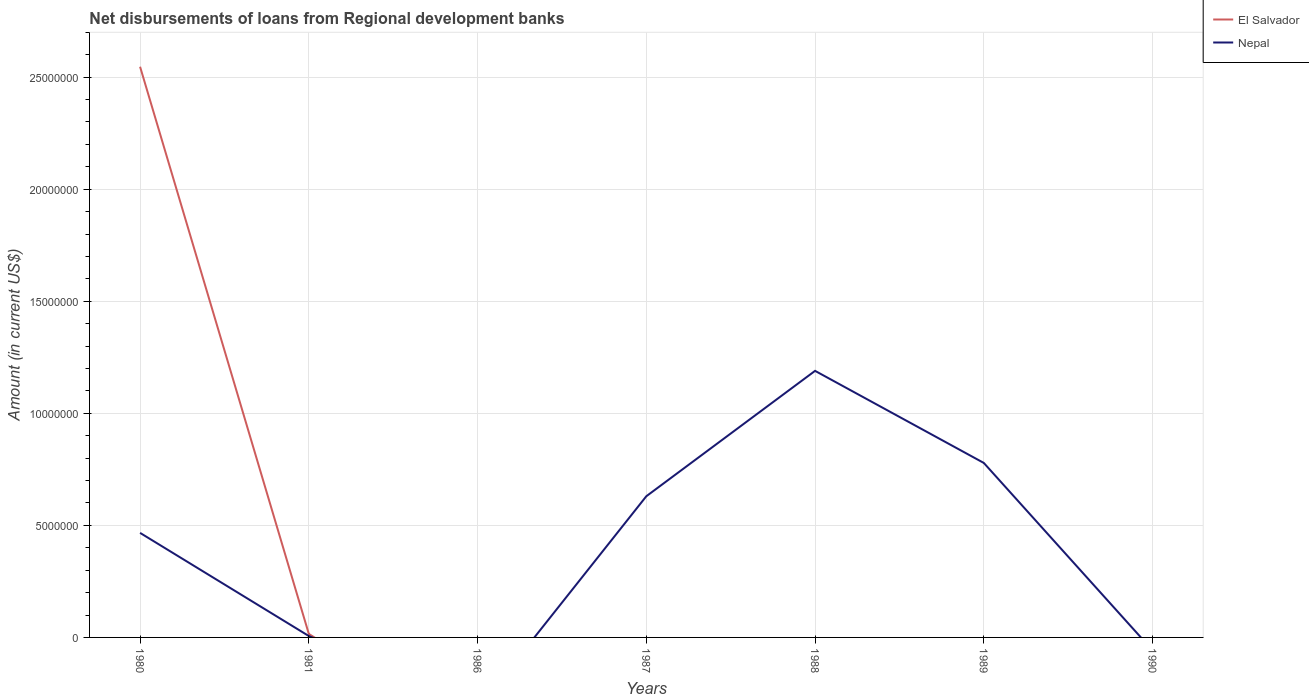How many different coloured lines are there?
Keep it short and to the point. 2. Does the line corresponding to Nepal intersect with the line corresponding to El Salvador?
Provide a succinct answer. Yes. Is the number of lines equal to the number of legend labels?
Make the answer very short. No. Across all years, what is the maximum amount of disbursements of loans from regional development banks in El Salvador?
Make the answer very short. 0. What is the total amount of disbursements of loans from regional development banks in Nepal in the graph?
Make the answer very short. -5.60e+06. What is the difference between the highest and the second highest amount of disbursements of loans from regional development banks in El Salvador?
Keep it short and to the point. 2.55e+07. Is the amount of disbursements of loans from regional development banks in Nepal strictly greater than the amount of disbursements of loans from regional development banks in El Salvador over the years?
Make the answer very short. No. How many years are there in the graph?
Offer a terse response. 7. Are the values on the major ticks of Y-axis written in scientific E-notation?
Provide a succinct answer. No. Does the graph contain any zero values?
Your answer should be very brief. Yes. How are the legend labels stacked?
Make the answer very short. Vertical. What is the title of the graph?
Offer a very short reply. Net disbursements of loans from Regional development banks. What is the label or title of the X-axis?
Your response must be concise. Years. What is the label or title of the Y-axis?
Provide a short and direct response. Amount (in current US$). What is the Amount (in current US$) in El Salvador in 1980?
Offer a very short reply. 2.55e+07. What is the Amount (in current US$) of Nepal in 1980?
Offer a terse response. 4.66e+06. What is the Amount (in current US$) of El Salvador in 1981?
Keep it short and to the point. 1.56e+05. What is the Amount (in current US$) in Nepal in 1981?
Offer a very short reply. 6.30e+04. What is the Amount (in current US$) in El Salvador in 1986?
Offer a very short reply. 0. What is the Amount (in current US$) in Nepal in 1986?
Offer a terse response. 0. What is the Amount (in current US$) in Nepal in 1987?
Offer a terse response. 6.30e+06. What is the Amount (in current US$) of El Salvador in 1988?
Make the answer very short. 0. What is the Amount (in current US$) in Nepal in 1988?
Your answer should be compact. 1.19e+07. What is the Amount (in current US$) in El Salvador in 1989?
Provide a succinct answer. 0. What is the Amount (in current US$) in Nepal in 1989?
Give a very brief answer. 7.79e+06. Across all years, what is the maximum Amount (in current US$) in El Salvador?
Make the answer very short. 2.55e+07. Across all years, what is the maximum Amount (in current US$) of Nepal?
Make the answer very short. 1.19e+07. Across all years, what is the minimum Amount (in current US$) in El Salvador?
Give a very brief answer. 0. Across all years, what is the minimum Amount (in current US$) in Nepal?
Provide a short and direct response. 0. What is the total Amount (in current US$) of El Salvador in the graph?
Provide a succinct answer. 2.56e+07. What is the total Amount (in current US$) of Nepal in the graph?
Your response must be concise. 3.07e+07. What is the difference between the Amount (in current US$) of El Salvador in 1980 and that in 1981?
Your answer should be compact. 2.53e+07. What is the difference between the Amount (in current US$) of Nepal in 1980 and that in 1981?
Your answer should be very brief. 4.60e+06. What is the difference between the Amount (in current US$) of Nepal in 1980 and that in 1987?
Your response must be concise. -1.64e+06. What is the difference between the Amount (in current US$) of Nepal in 1980 and that in 1988?
Make the answer very short. -7.23e+06. What is the difference between the Amount (in current US$) in Nepal in 1980 and that in 1989?
Your answer should be compact. -3.12e+06. What is the difference between the Amount (in current US$) in Nepal in 1981 and that in 1987?
Provide a succinct answer. -6.24e+06. What is the difference between the Amount (in current US$) in Nepal in 1981 and that in 1988?
Give a very brief answer. -1.18e+07. What is the difference between the Amount (in current US$) of Nepal in 1981 and that in 1989?
Offer a terse response. -7.72e+06. What is the difference between the Amount (in current US$) of Nepal in 1987 and that in 1988?
Offer a terse response. -5.60e+06. What is the difference between the Amount (in current US$) of Nepal in 1987 and that in 1989?
Keep it short and to the point. -1.49e+06. What is the difference between the Amount (in current US$) of Nepal in 1988 and that in 1989?
Offer a very short reply. 4.11e+06. What is the difference between the Amount (in current US$) in El Salvador in 1980 and the Amount (in current US$) in Nepal in 1981?
Offer a terse response. 2.54e+07. What is the difference between the Amount (in current US$) of El Salvador in 1980 and the Amount (in current US$) of Nepal in 1987?
Offer a very short reply. 1.92e+07. What is the difference between the Amount (in current US$) in El Salvador in 1980 and the Amount (in current US$) in Nepal in 1988?
Ensure brevity in your answer.  1.36e+07. What is the difference between the Amount (in current US$) of El Salvador in 1980 and the Amount (in current US$) of Nepal in 1989?
Provide a succinct answer. 1.77e+07. What is the difference between the Amount (in current US$) of El Salvador in 1981 and the Amount (in current US$) of Nepal in 1987?
Your response must be concise. -6.14e+06. What is the difference between the Amount (in current US$) of El Salvador in 1981 and the Amount (in current US$) of Nepal in 1988?
Make the answer very short. -1.17e+07. What is the difference between the Amount (in current US$) of El Salvador in 1981 and the Amount (in current US$) of Nepal in 1989?
Give a very brief answer. -7.63e+06. What is the average Amount (in current US$) in El Salvador per year?
Offer a very short reply. 3.66e+06. What is the average Amount (in current US$) in Nepal per year?
Your response must be concise. 4.39e+06. In the year 1980, what is the difference between the Amount (in current US$) in El Salvador and Amount (in current US$) in Nepal?
Your answer should be very brief. 2.08e+07. In the year 1981, what is the difference between the Amount (in current US$) of El Salvador and Amount (in current US$) of Nepal?
Your answer should be compact. 9.30e+04. What is the ratio of the Amount (in current US$) in El Salvador in 1980 to that in 1981?
Give a very brief answer. 163.24. What is the ratio of the Amount (in current US$) in Nepal in 1980 to that in 1981?
Give a very brief answer. 74.05. What is the ratio of the Amount (in current US$) of Nepal in 1980 to that in 1987?
Your answer should be very brief. 0.74. What is the ratio of the Amount (in current US$) of Nepal in 1980 to that in 1988?
Provide a succinct answer. 0.39. What is the ratio of the Amount (in current US$) of Nepal in 1980 to that in 1989?
Your response must be concise. 0.6. What is the ratio of the Amount (in current US$) in Nepal in 1981 to that in 1988?
Give a very brief answer. 0.01. What is the ratio of the Amount (in current US$) in Nepal in 1981 to that in 1989?
Offer a terse response. 0.01. What is the ratio of the Amount (in current US$) of Nepal in 1987 to that in 1988?
Your response must be concise. 0.53. What is the ratio of the Amount (in current US$) in Nepal in 1987 to that in 1989?
Your response must be concise. 0.81. What is the ratio of the Amount (in current US$) in Nepal in 1988 to that in 1989?
Your response must be concise. 1.53. What is the difference between the highest and the second highest Amount (in current US$) in Nepal?
Your answer should be very brief. 4.11e+06. What is the difference between the highest and the lowest Amount (in current US$) in El Salvador?
Ensure brevity in your answer.  2.55e+07. What is the difference between the highest and the lowest Amount (in current US$) of Nepal?
Provide a succinct answer. 1.19e+07. 